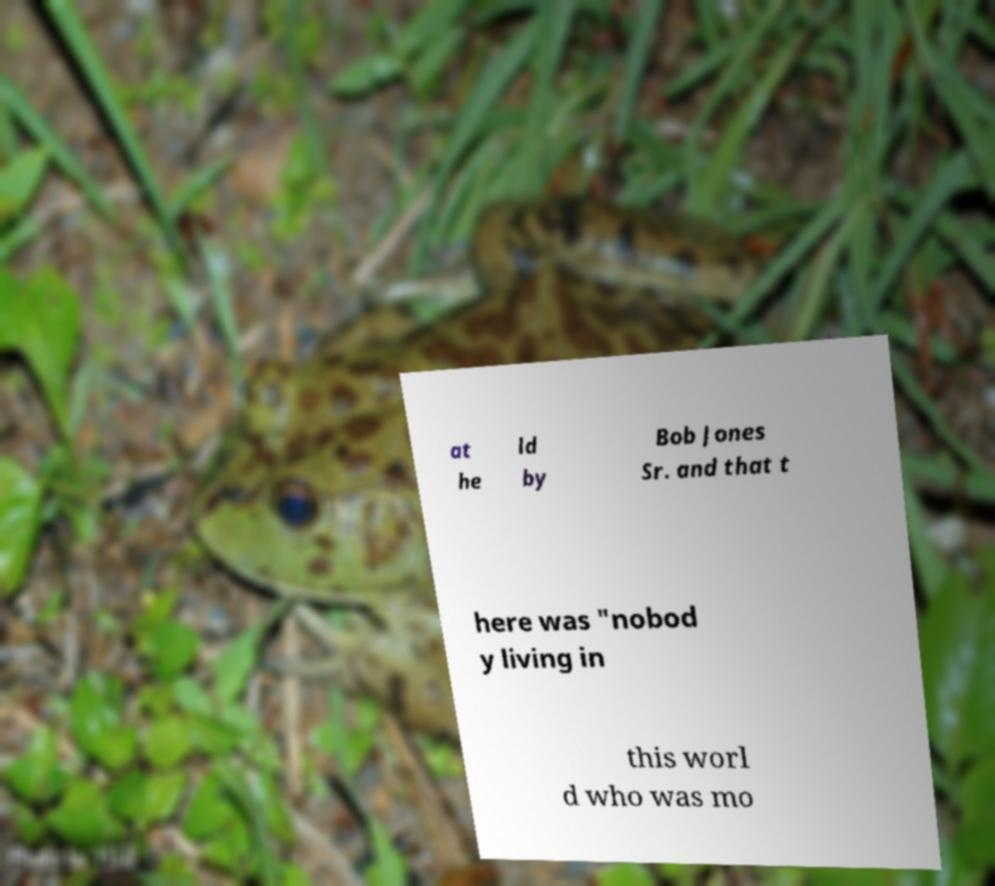What messages or text are displayed in this image? I need them in a readable, typed format. at he ld by Bob Jones Sr. and that t here was "nobod y living in this worl d who was mo 